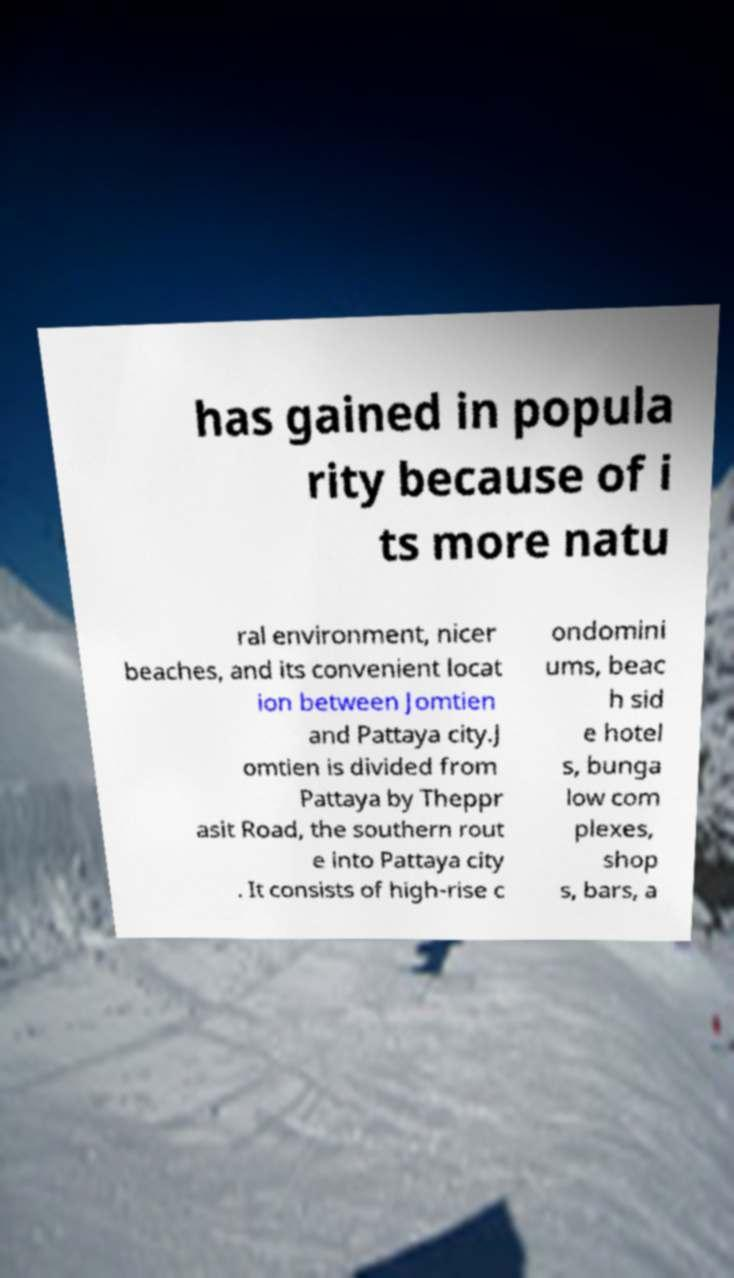Could you extract and type out the text from this image? has gained in popula rity because of i ts more natu ral environment, nicer beaches, and its convenient locat ion between Jomtien and Pattaya city.J omtien is divided from Pattaya by Theppr asit Road, the southern rout e into Pattaya city . It consists of high-rise c ondomini ums, beac h sid e hotel s, bunga low com plexes, shop s, bars, a 